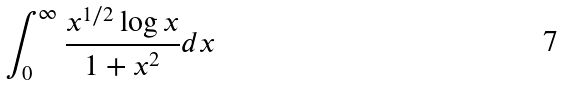Convert formula to latex. <formula><loc_0><loc_0><loc_500><loc_500>\int _ { 0 } ^ { \infty } \frac { x ^ { 1 / 2 } \log x } { 1 + x ^ { 2 } } d x</formula> 